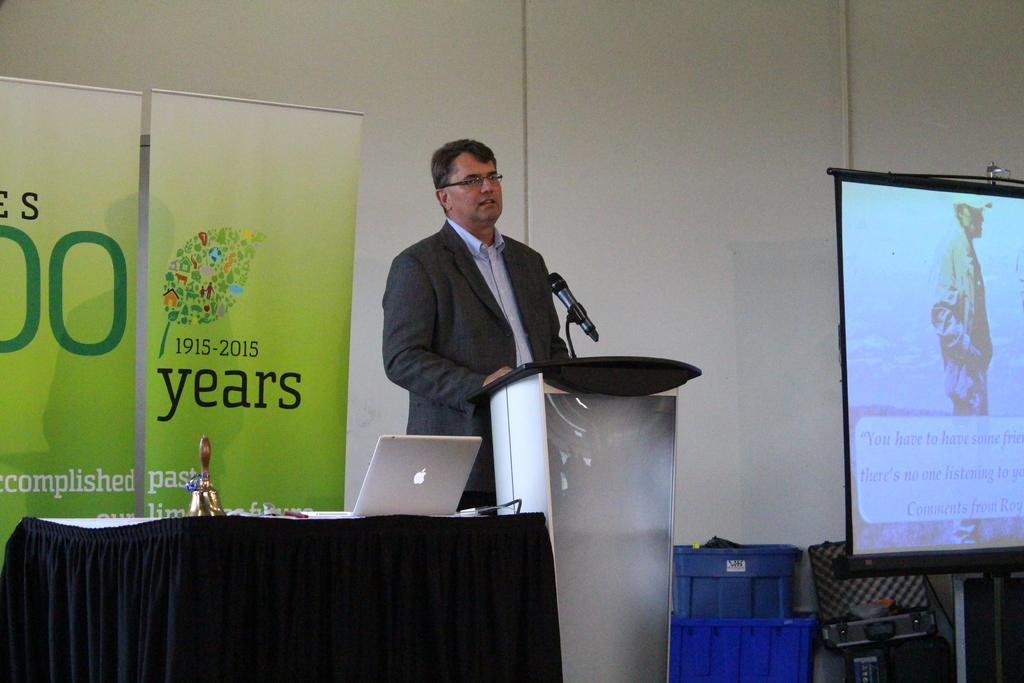How many years has this company been going?
Provide a succinct answer. 100. 